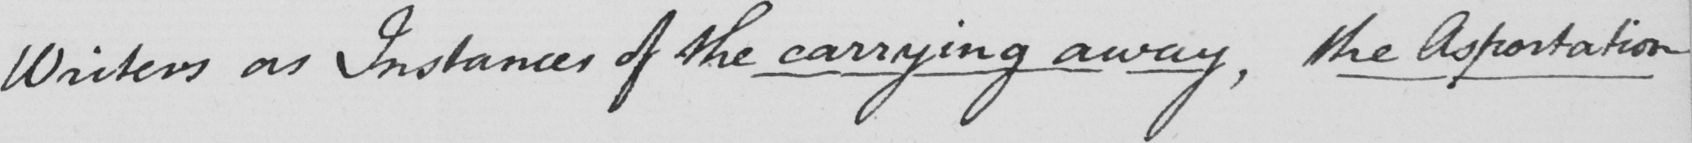What does this handwritten line say? Writers as Instances of the carrying away , the Asportation 